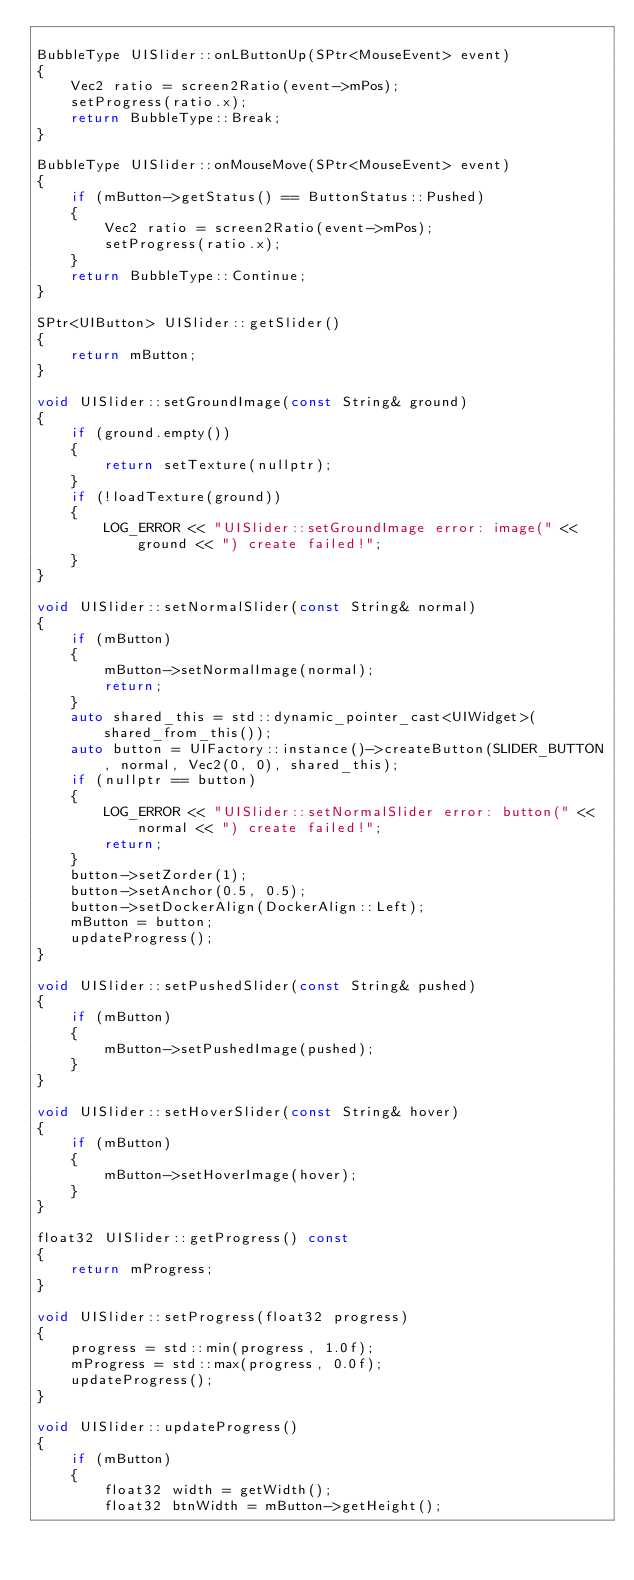Convert code to text. <code><loc_0><loc_0><loc_500><loc_500><_C++_>
BubbleType UISlider::onLButtonUp(SPtr<MouseEvent> event)
{
    Vec2 ratio = screen2Ratio(event->mPos);
    setProgress(ratio.x);
    return BubbleType::Break;
}

BubbleType UISlider::onMouseMove(SPtr<MouseEvent> event)
{
    if (mButton->getStatus() == ButtonStatus::Pushed)
    {
        Vec2 ratio = screen2Ratio(event->mPos);
        setProgress(ratio.x);
    }
    return BubbleType::Continue;
}

SPtr<UIButton> UISlider::getSlider()
{
    return mButton;
}

void UISlider::setGroundImage(const String& ground)
{
    if (ground.empty())
    {
        return setTexture(nullptr);
    }
    if (!loadTexture(ground))
    {
        LOG_ERROR << "UISlider::setGroundImage error: image(" << ground << ") create failed!";
    }
}

void UISlider::setNormalSlider(const String& normal)
{
    if (mButton)
    {
        mButton->setNormalImage(normal);
        return;
    }
    auto shared_this = std::dynamic_pointer_cast<UIWidget>(shared_from_this());
    auto button = UIFactory::instance()->createButton(SLIDER_BUTTON, normal, Vec2(0, 0), shared_this);
    if (nullptr == button)
    {
        LOG_ERROR << "UISlider::setNormalSlider error: button(" << normal << ") create failed!";
        return;
    }
    button->setZorder(1);
    button->setAnchor(0.5, 0.5);
    button->setDockerAlign(DockerAlign::Left);
    mButton = button;
    updateProgress();
}

void UISlider::setPushedSlider(const String& pushed)
{
    if (mButton)
    {
        mButton->setPushedImage(pushed);
    }
}

void UISlider::setHoverSlider(const String& hover)
{
    if (mButton)
    {
        mButton->setHoverImage(hover);
    }
}

float32 UISlider::getProgress() const
{
    return mProgress;
}

void UISlider::setProgress(float32 progress)
{
    progress = std::min(progress, 1.0f);
    mProgress = std::max(progress, 0.0f);
    updateProgress();
}

void UISlider::updateProgress()
{
    if (mButton)
    {
        float32 width = getWidth();
        float32 btnWidth = mButton->getHeight();</code> 